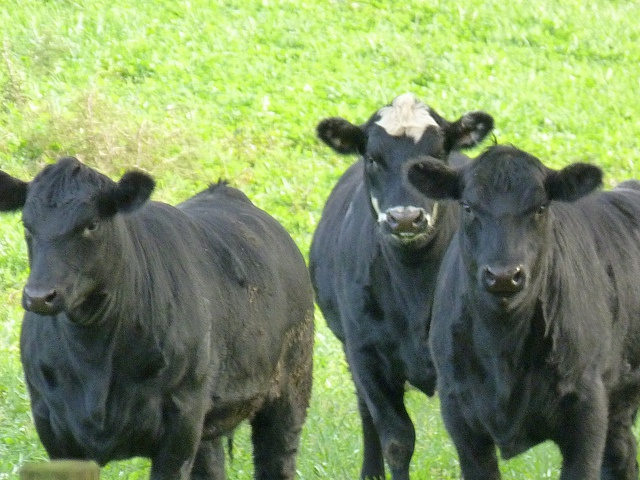Describe the objects in this image and their specific colors. I can see cow in yellow, gray, black, purple, and darkgreen tones, cow in yellow, gray, black, and purple tones, and cow in yellow, gray, black, purple, and ivory tones in this image. 